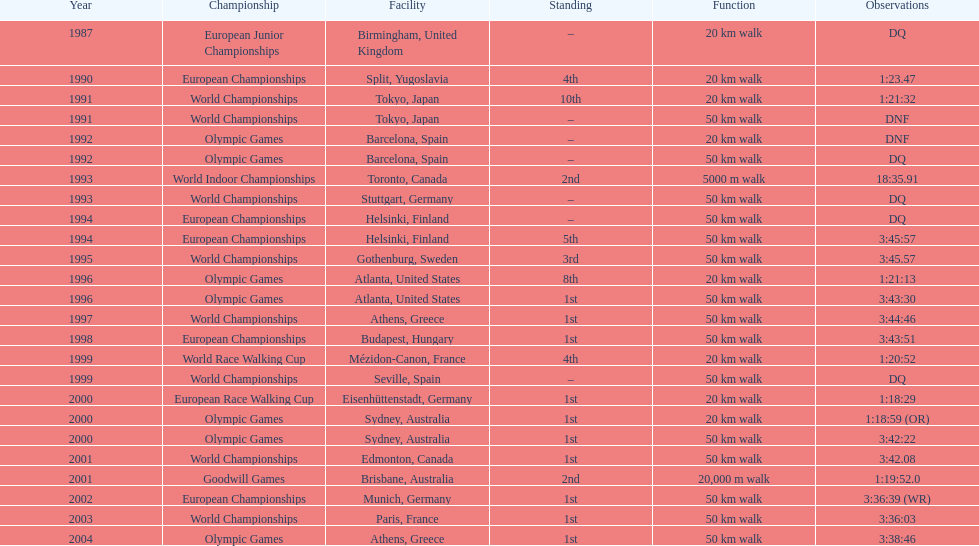How many times was korzeniowski disqualified from a competition? 5. 